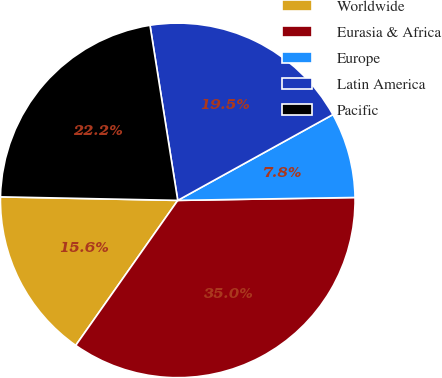Convert chart to OTSL. <chart><loc_0><loc_0><loc_500><loc_500><pie_chart><fcel>Worldwide<fcel>Eurasia & Africa<fcel>Europe<fcel>Latin America<fcel>Pacific<nl><fcel>15.56%<fcel>35.02%<fcel>7.78%<fcel>19.46%<fcel>22.18%<nl></chart> 